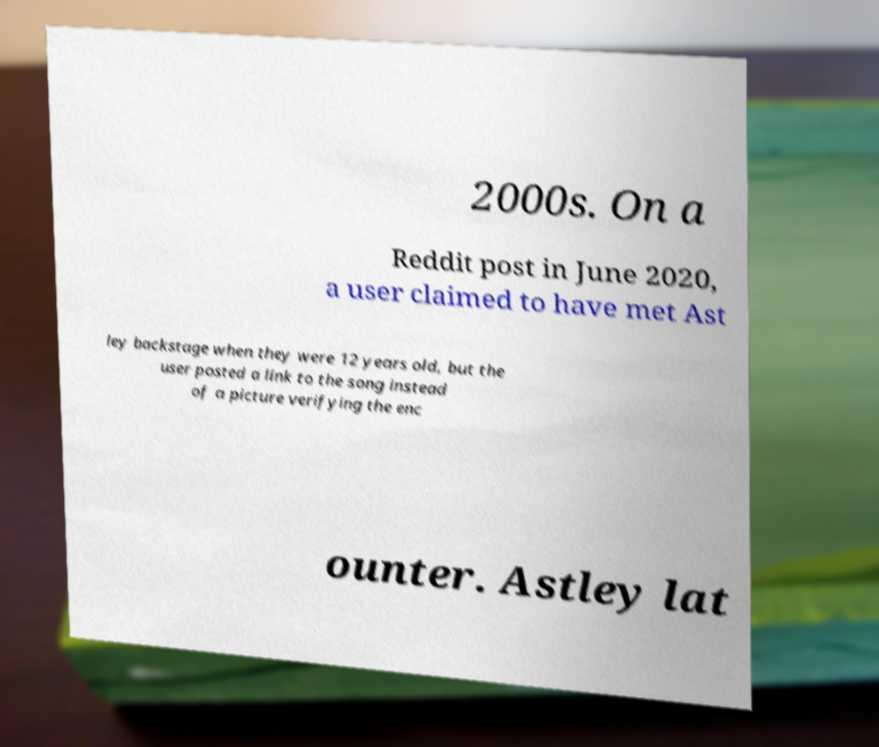Could you extract and type out the text from this image? 2000s. On a Reddit post in June 2020, a user claimed to have met Ast ley backstage when they were 12 years old, but the user posted a link to the song instead of a picture verifying the enc ounter. Astley lat 